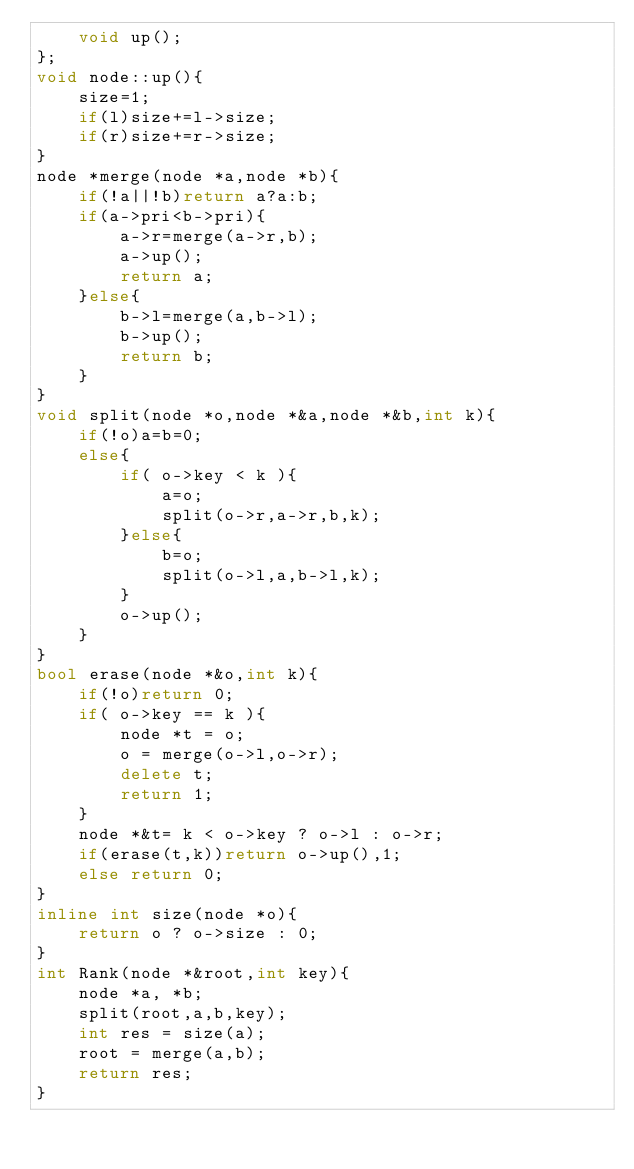Convert code to text. <code><loc_0><loc_0><loc_500><loc_500><_C++_>    void up();
};
void node::up(){
    size=1;
    if(l)size+=l->size;
    if(r)size+=r->size;
}
node *merge(node *a,node *b){
    if(!a||!b)return a?a:b;
    if(a->pri<b->pri){
        a->r=merge(a->r,b);
        a->up();
        return a;
    }else{
        b->l=merge(a,b->l);
        b->up();
        return b;
    }
}
void split(node *o,node *&a,node *&b,int k){
    if(!o)a=b=0;
    else{
        if( o->key < k ){
            a=o;
            split(o->r,a->r,b,k);
        }else{
            b=o;
            split(o->l,a,b->l,k);
        }
        o->up();
    }
}
bool erase(node *&o,int k){
    if(!o)return 0;
    if( o->key == k ){
        node *t = o;
        o = merge(o->l,o->r);
        delete t;
        return 1;
    }
    node *&t= k < o->key ? o->l : o->r;
    if(erase(t,k))return o->up(),1;
    else return 0;
}
inline int size(node *o){
    return o ? o->size : 0;
}
int Rank(node *&root,int key){
    node *a, *b;
    split(root,a,b,key);
    int res = size(a);
    root = merge(a,b);
    return res;
}</code> 